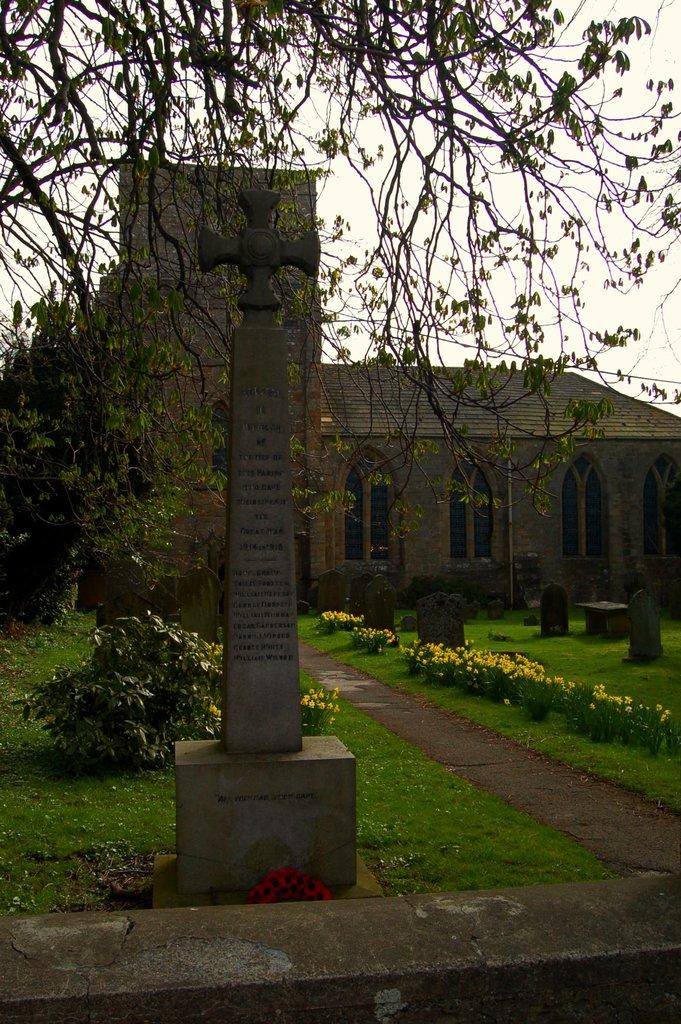What is the main object in the foreground of the image? There is a memorial stone in the image. What can be seen in the background of the image? There is a building with windows, a tree, plants, and grass in the background. What type of feather is attached to the mask worn by the girl in the image? There is no girl or mask present in the image; it features a memorial stone and a background with a building, tree, plants, and grass. 